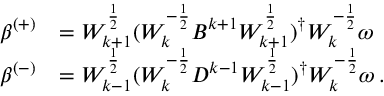<formula> <loc_0><loc_0><loc_500><loc_500>\begin{array} { r l } { \beta ^ { ( + ) } } & { = W _ { k + 1 } ^ { \frac { 1 } { 2 } } ( W _ { k } ^ { - \frac { 1 } { 2 } } B ^ { k + 1 } W _ { k + 1 } ^ { \frac { 1 } { 2 } } ) ^ { \dagger } W _ { k } ^ { - \frac { 1 } { 2 } } \omega } \\ { \beta ^ { ( - ) } } & { = W _ { k - 1 } ^ { \frac { 1 } { 2 } } ( W _ { k } ^ { - \frac { 1 } { 2 } } D ^ { k - 1 } W _ { k - 1 } ^ { \frac { 1 } { 2 } } ) ^ { \dagger } W _ { k } ^ { - \frac { 1 } { 2 } } \omega \, . } \end{array}</formula> 